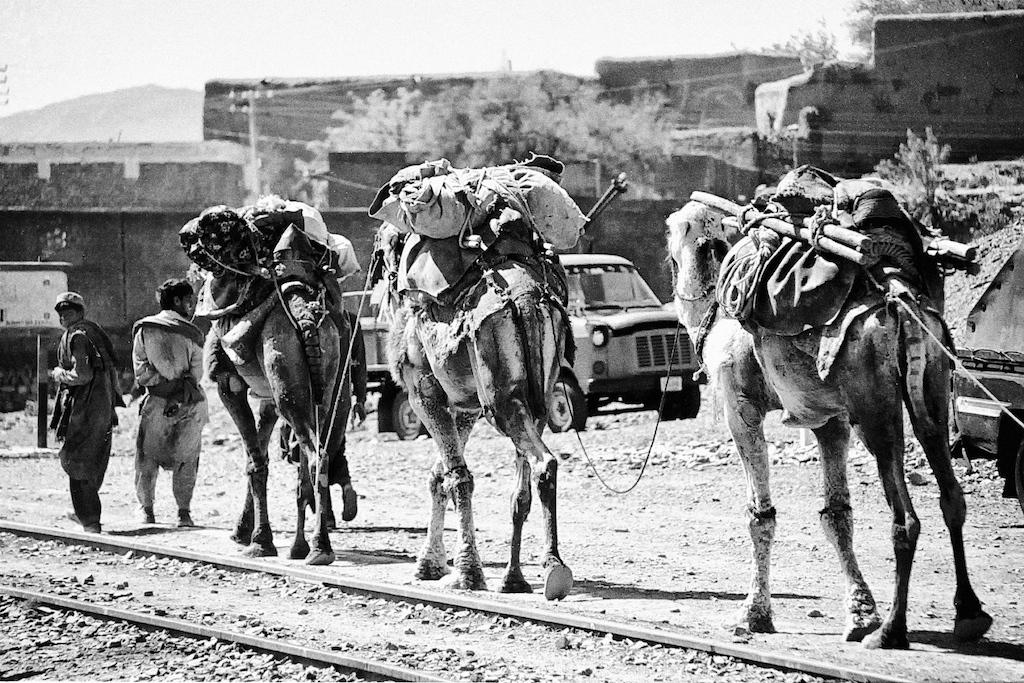What can be seen in the image related to animals? There are three animals with luggage in the image. How many men are present in the image? There are two men standing in the image. What is in front of the men in the image? There are buildings in front of the men in the image. What type of natural elements can be seen in the image? There are trees in the image. What type of leather is visible on the books in the image? There are no books present in the image, so there is no leather to be seen. 